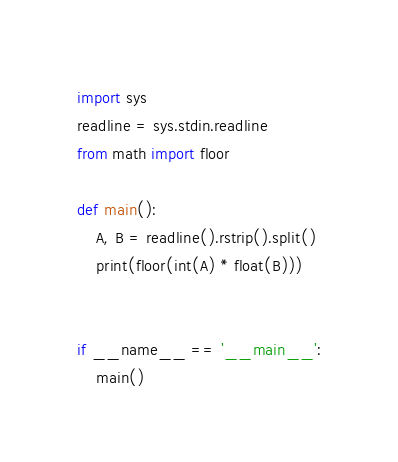<code> <loc_0><loc_0><loc_500><loc_500><_Python_>import sys
readline = sys.stdin.readline
from math import floor

def main():
    A, B = readline().rstrip().split()
    print(floor(int(A) * float(B)))


if __name__ == '__main__':
    main()</code> 